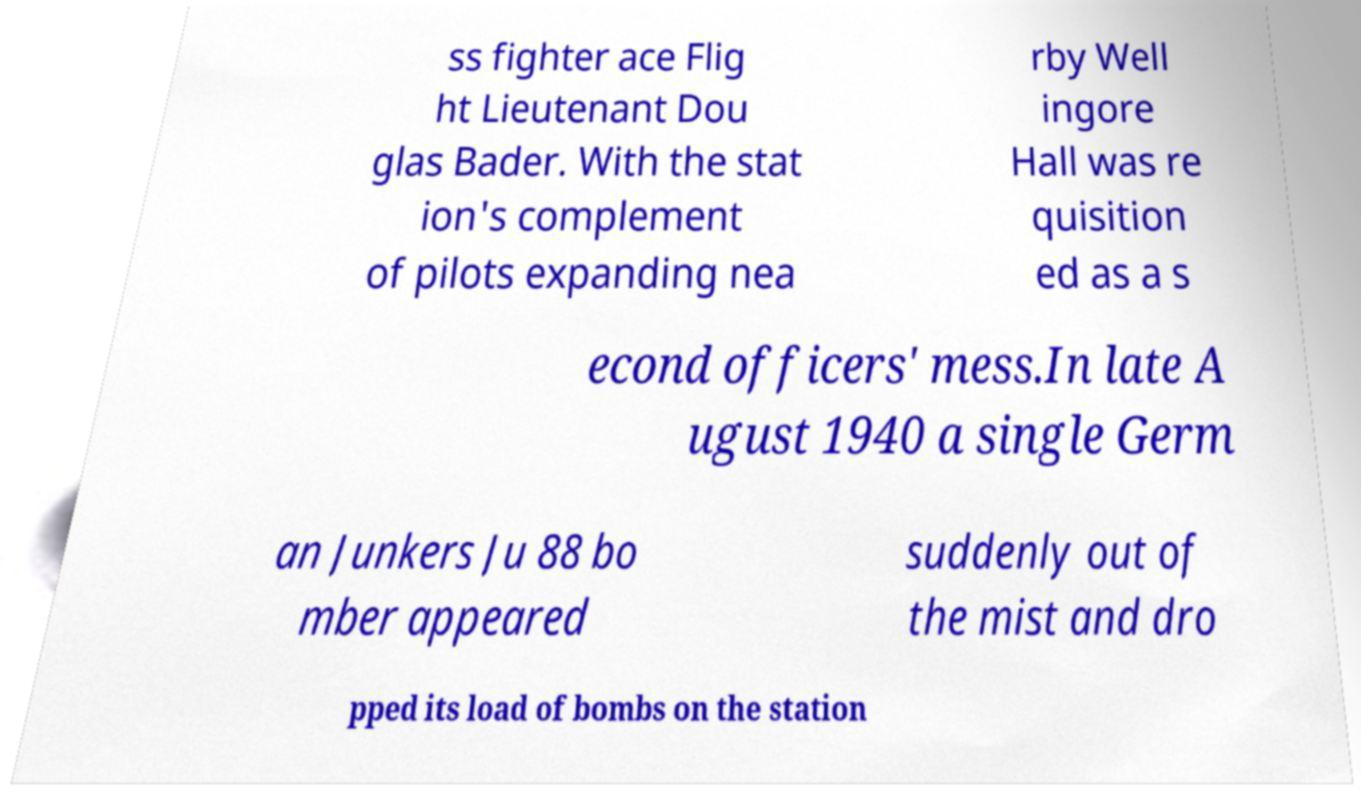What messages or text are displayed in this image? I need them in a readable, typed format. ss fighter ace Flig ht Lieutenant Dou glas Bader. With the stat ion's complement of pilots expanding nea rby Well ingore Hall was re quisition ed as a s econd officers' mess.In late A ugust 1940 a single Germ an Junkers Ju 88 bo mber appeared suddenly out of the mist and dro pped its load of bombs on the station 